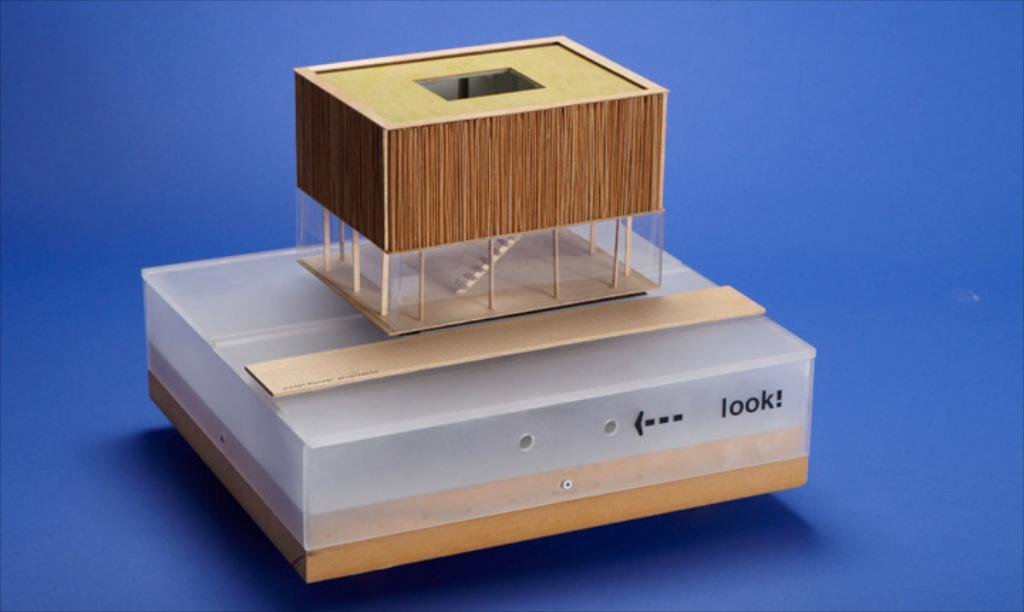Provide a one-sentence caption for the provided image. A plastic box with "look" written next to a peep hole with a ruler and small box on top of it. 